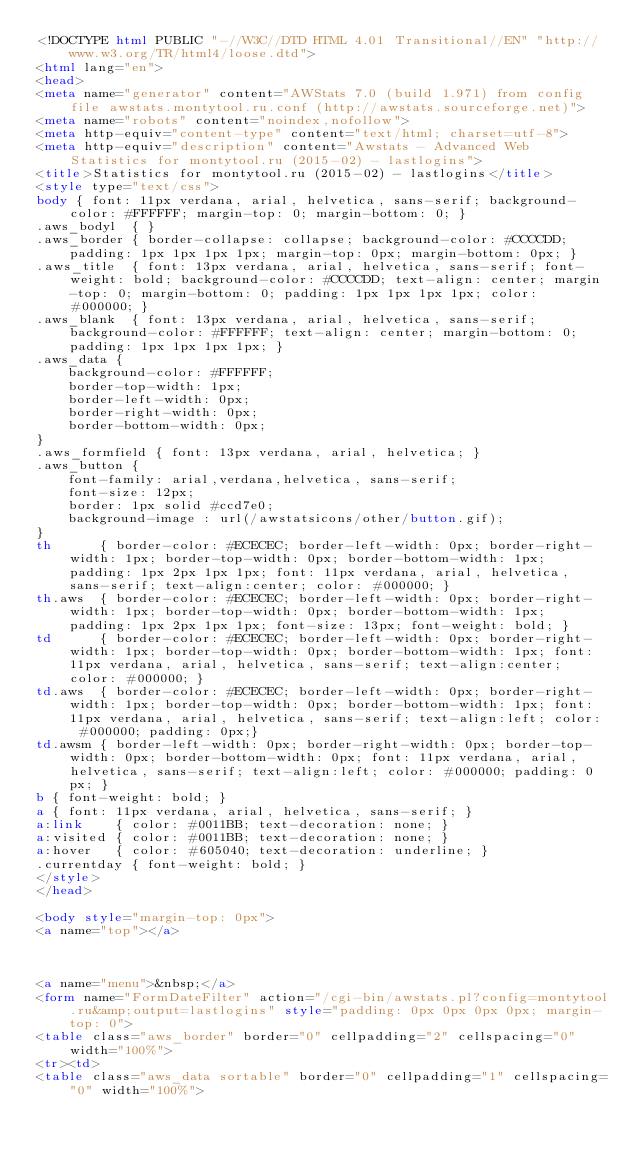Convert code to text. <code><loc_0><loc_0><loc_500><loc_500><_HTML_><!DOCTYPE html PUBLIC "-//W3C//DTD HTML 4.01 Transitional//EN" "http://www.w3.org/TR/html4/loose.dtd">
<html lang="en">
<head>
<meta name="generator" content="AWStats 7.0 (build 1.971) from config file awstats.montytool.ru.conf (http://awstats.sourceforge.net)">
<meta name="robots" content="noindex,nofollow">
<meta http-equiv="content-type" content="text/html; charset=utf-8">
<meta http-equiv="description" content="Awstats - Advanced Web Statistics for montytool.ru (2015-02) - lastlogins">
<title>Statistics for montytool.ru (2015-02) - lastlogins</title>
<style type="text/css">
body { font: 11px verdana, arial, helvetica, sans-serif; background-color: #FFFFFF; margin-top: 0; margin-bottom: 0; }
.aws_bodyl  { }
.aws_border { border-collapse: collapse; background-color: #CCCCDD; padding: 1px 1px 1px 1px; margin-top: 0px; margin-bottom: 0px; }
.aws_title  { font: 13px verdana, arial, helvetica, sans-serif; font-weight: bold; background-color: #CCCCDD; text-align: center; margin-top: 0; margin-bottom: 0; padding: 1px 1px 1px 1px; color: #000000; }
.aws_blank  { font: 13px verdana, arial, helvetica, sans-serif; background-color: #FFFFFF; text-align: center; margin-bottom: 0; padding: 1px 1px 1px 1px; }
.aws_data {
	background-color: #FFFFFF;
	border-top-width: 1px;   
	border-left-width: 0px;  
	border-right-width: 0px; 
	border-bottom-width: 0px;
}
.aws_formfield { font: 13px verdana, arial, helvetica; }
.aws_button {
	font-family: arial,verdana,helvetica, sans-serif;
	font-size: 12px;
	border: 1px solid #ccd7e0;
	background-image : url(/awstatsicons/other/button.gif);
}
th		{ border-color: #ECECEC; border-left-width: 0px; border-right-width: 1px; border-top-width: 0px; border-bottom-width: 1px; padding: 1px 2px 1px 1px; font: 11px verdana, arial, helvetica, sans-serif; text-align:center; color: #000000; }
th.aws	{ border-color: #ECECEC; border-left-width: 0px; border-right-width: 1px; border-top-width: 0px; border-bottom-width: 1px; padding: 1px 2px 1px 1px; font-size: 13px; font-weight: bold; }
td		{ border-color: #ECECEC; border-left-width: 0px; border-right-width: 1px; border-top-width: 0px; border-bottom-width: 1px; font: 11px verdana, arial, helvetica, sans-serif; text-align:center; color: #000000; }
td.aws	{ border-color: #ECECEC; border-left-width: 0px; border-right-width: 1px; border-top-width: 0px; border-bottom-width: 1px; font: 11px verdana, arial, helvetica, sans-serif; text-align:left; color: #000000; padding: 0px;}
td.awsm	{ border-left-width: 0px; border-right-width: 0px; border-top-width: 0px; border-bottom-width: 0px; font: 11px verdana, arial, helvetica, sans-serif; text-align:left; color: #000000; padding: 0px; }
b { font-weight: bold; }
a { font: 11px verdana, arial, helvetica, sans-serif; }
a:link    { color: #0011BB; text-decoration: none; }
a:visited { color: #0011BB; text-decoration: none; }
a:hover   { color: #605040; text-decoration: underline; }
.currentday { font-weight: bold; }
</style>
</head>

<body style="margin-top: 0px">
<a name="top"></a>



<a name="menu">&nbsp;</a>
<form name="FormDateFilter" action="/cgi-bin/awstats.pl?config=montytool.ru&amp;output=lastlogins" style="padding: 0px 0px 0px 0px; margin-top: 0">
<table class="aws_border" border="0" cellpadding="2" cellspacing="0" width="100%">
<tr><td>
<table class="aws_data sortable" border="0" cellpadding="1" cellspacing="0" width="100%"></code> 